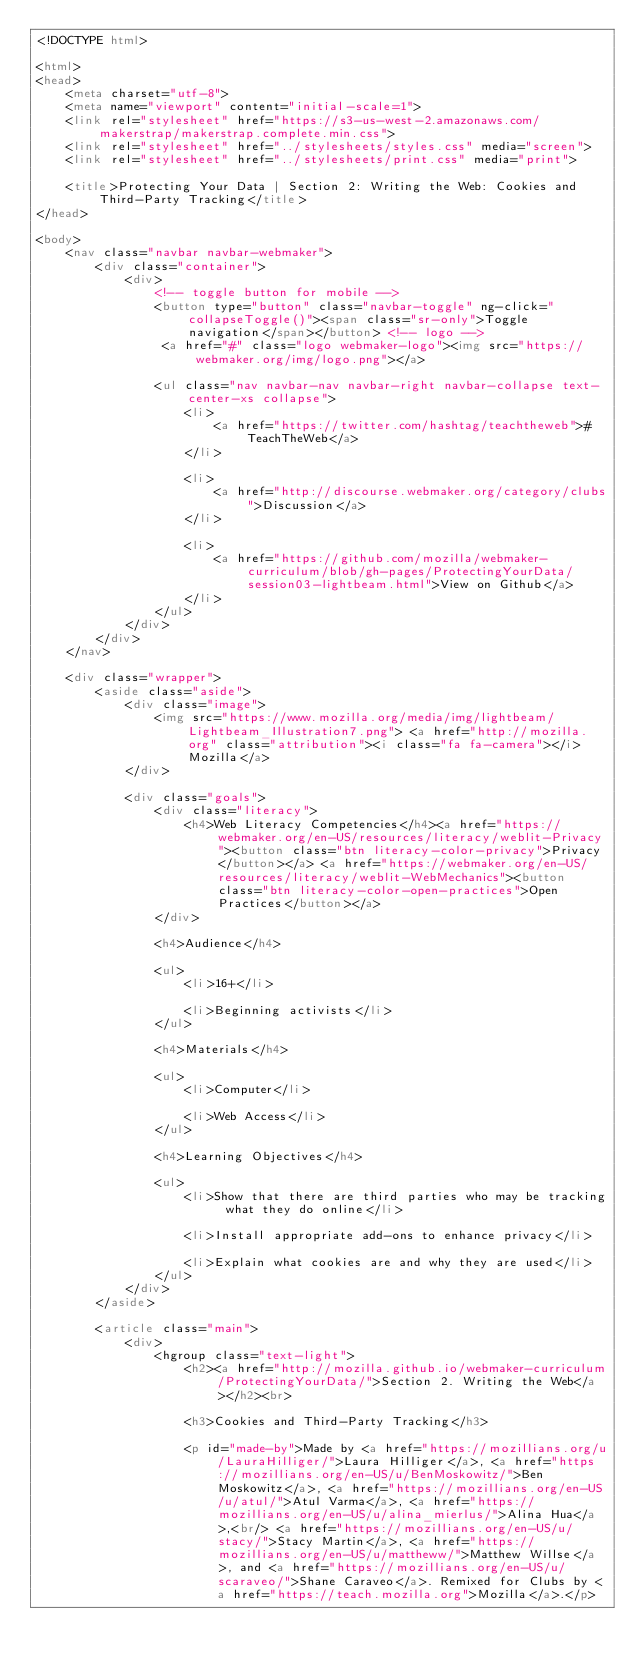Convert code to text. <code><loc_0><loc_0><loc_500><loc_500><_HTML_><!DOCTYPE html>

<html>
<head>
    <meta charset="utf-8">
    <meta name="viewport" content="initial-scale=1">
    <link rel="stylesheet" href="https://s3-us-west-2.amazonaws.com/makerstrap/makerstrap.complete.min.css">
    <link rel="stylesheet" href="../stylesheets/styles.css" media="screen">
    <link rel="stylesheet" href="../stylesheets/print.css" media="print">

    <title>Protecting Your Data | Section 2: Writing the Web: Cookies and Third-Party Tracking</title>
</head>

<body>
    <nav class="navbar navbar-webmaker">
        <div class="container">
            <div>
                <!-- toggle button for mobile -->
                <button type="button" class="navbar-toggle" ng-click="collapseToggle()"><span class="sr-only">Toggle navigation</span></button> <!-- logo -->
                 <a href="#" class="logo webmaker-logo"><img src="https://webmaker.org/img/logo.png"></a>

                <ul class="nav navbar-nav navbar-right navbar-collapse text-center-xs collapse">
                    <li>
                        <a href="https://twitter.com/hashtag/teachtheweb">#TeachTheWeb</a>
                    </li>

                    <li>
                        <a href="http://discourse.webmaker.org/category/clubs">Discussion</a>
                    </li>

                    <li>
                        <a href="https://github.com/mozilla/webmaker-curriculum/blob/gh-pages/ProtectingYourData/session03-lightbeam.html">View on Github</a>
                    </li>
                </ul>
            </div>
        </div>
    </nav>

    <div class="wrapper">
        <aside class="aside">
            <div class="image">
                <img src="https://www.mozilla.org/media/img/lightbeam/Lightbeam_Illustration7.png"> <a href="http://mozilla.org" class="attribution"><i class="fa fa-camera"></i> Mozilla</a>
            </div>

            <div class="goals">
                <div class="literacy">
                    <h4>Web Literacy Competencies</h4><a href="https://webmaker.org/en-US/resources/literacy/weblit-Privacy"><button class="btn literacy-color-privacy">Privacy</button></a> <a href="https://webmaker.org/en-US/resources/literacy/weblit-WebMechanics"><button class="btn literacy-color-open-practices">Open Practices</button></a>
                </div>

                <h4>Audience</h4>

                <ul>
                    <li>16+</li>

                    <li>Beginning activists</li>
                </ul>

                <h4>Materials</h4>

                <ul>
                    <li>Computer</li>

                    <li>Web Access</li>
                </ul>

                <h4>Learning Objectives</h4>

                <ul>
                    <li>Show that there are third parties who may be tracking what they do online</li>

                    <li>Install appropriate add-ons to enhance privacy</li>
                    
                    <li>Explain what cookies are and why they are used</li>
                </ul>
            </div>
        </aside>

        <article class="main">
            <div>
                <hgroup class="text-light">
                    <h2><a href="http://mozilla.github.io/webmaker-curriculum/ProtectingYourData/">Section 2. Writing the Web</a></h2><br>

                    <h3>Cookies and Third-Party Tracking</h3>

                    <p id="made-by">Made by <a href="https://mozillians.org/u/LauraHilliger/">Laura Hilliger</a>, <a href="https://mozillians.org/en-US/u/BenMoskowitz/">Ben Moskowitz</a>, <a href="https://mozillians.org/en-US/u/atul/">Atul Varma</a>, <a href="https://mozillians.org/en-US/u/alina_mierlus/">Alina Hua</a>,<br/> <a href="https://mozillians.org/en-US/u/stacy/">Stacy Martin</a>, <a href="https://mozillians.org/en-US/u/mattheww/">Matthew Willse</a>, and <a href="https://mozillians.org/en-US/u/scaraveo/">Shane Caraveo</a>. Remixed for Clubs by <a href="https://teach.mozilla.org">Mozilla</a>.</p>
</code> 